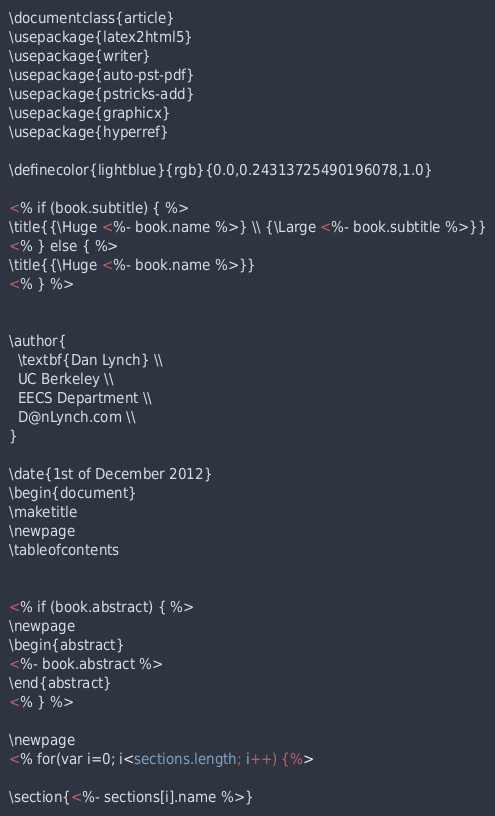<code> <loc_0><loc_0><loc_500><loc_500><_HTML_>\documentclass{article}
\usepackage{latex2html5}
\usepackage{writer}
\usepackage{auto-pst-pdf}
\usepackage{pstricks-add}
\usepackage{graphicx}
\usepackage{hyperref}

\definecolor{lightblue}{rgb}{0.0,0.24313725490196078,1.0}

<% if (book.subtitle) { %>
\title{{\Huge <%- book.name %>} \\ {\Large <%- book.subtitle %>}}
<% } else { %>
\title{{\Huge <%- book.name %>}}
<% } %>


\author{
  \textbf{Dan Lynch} \\
  UC Berkeley \\
  EECS Department \\
  D@nLynch.com \\
}

\date{1st of December 2012}
\begin{document}
\maketitle
\newpage
\tableofcontents


<% if (book.abstract) { %>
\newpage
\begin{abstract}
<%- book.abstract %>
\end{abstract}
<% } %>

\newpage
<% for(var i=0; i<sections.length; i++) {%>

\section{<%- sections[i].name %>}</code> 